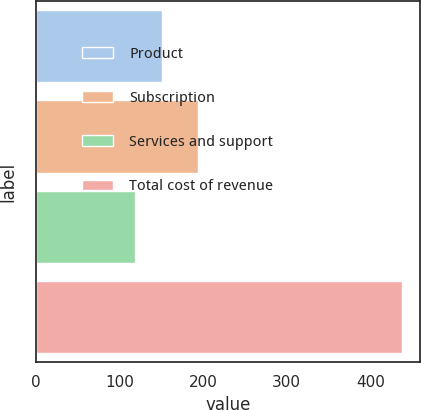Convert chart. <chart><loc_0><loc_0><loc_500><loc_500><bar_chart><fcel>Product<fcel>Subscription<fcel>Services and support<fcel>Total cost of revenue<nl><fcel>150.17<fcel>194<fcel>118.2<fcel>437.9<nl></chart> 